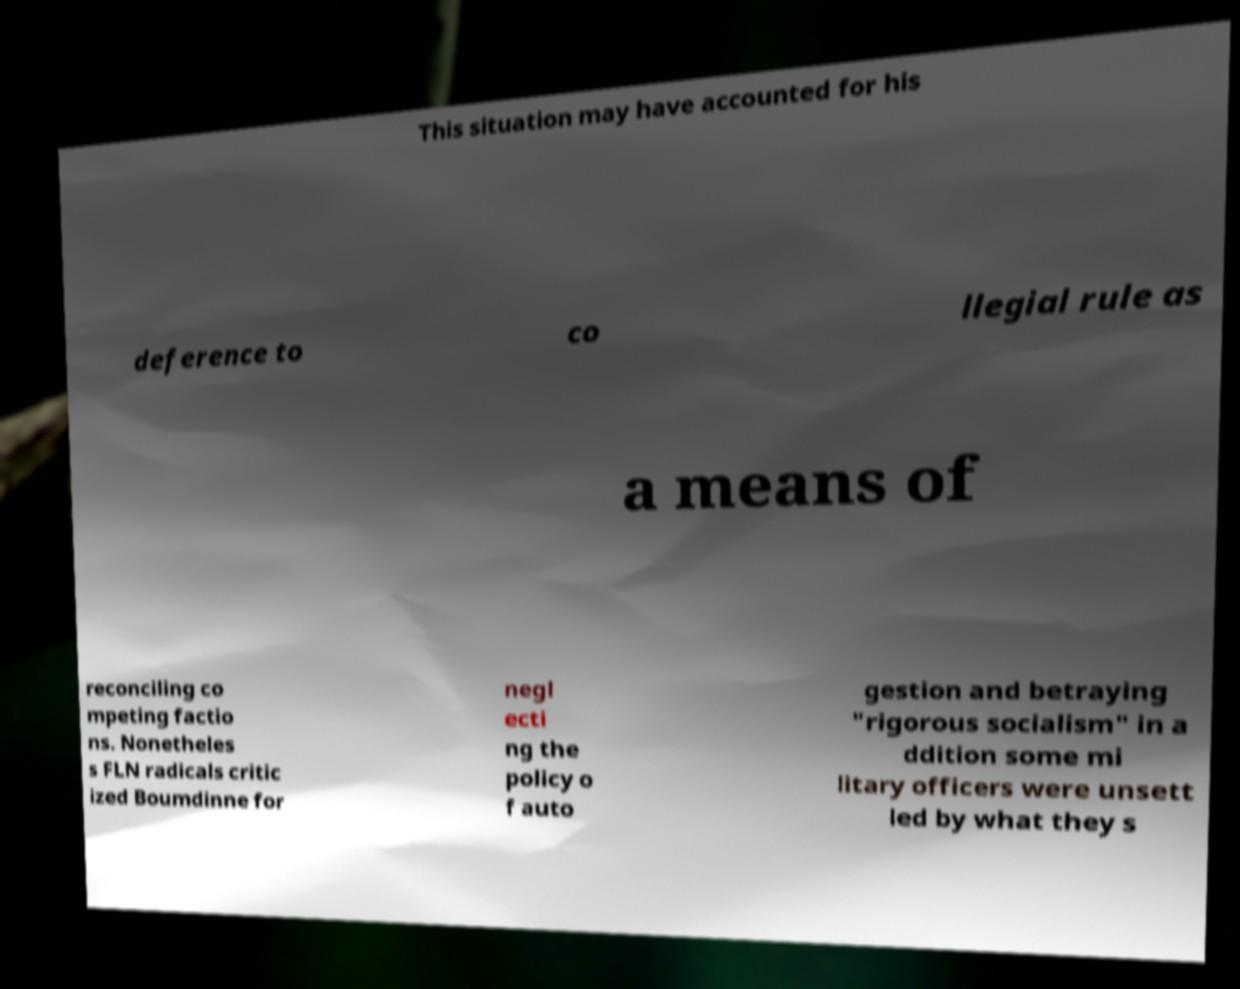I need the written content from this picture converted into text. Can you do that? This situation may have accounted for his deference to co llegial rule as a means of reconciling co mpeting factio ns. Nonetheles s FLN radicals critic ized Boumdinne for negl ecti ng the policy o f auto gestion and betraying "rigorous socialism" in a ddition some mi litary officers were unsett led by what they s 